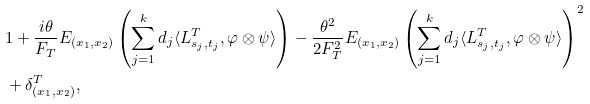<formula> <loc_0><loc_0><loc_500><loc_500>& 1 + \frac { i \theta } { F _ { T } } E _ { ( x _ { 1 } , x _ { 2 } ) } \left ( \sum _ { j = 1 } ^ { k } d _ { j } \langle L ^ { T } _ { s _ { j } , t _ { j } } , \varphi \otimes \psi \rangle \right ) - \frac { \theta ^ { 2 } } { 2 F _ { T } ^ { 2 } } E _ { ( x _ { 1 } , x _ { 2 } ) } \left ( \sum _ { j = 1 } ^ { k } d _ { j } \langle L ^ { T } _ { s _ { j } , t _ { j } } , \varphi \otimes \psi \rangle \right ) ^ { 2 } \\ & + \delta _ { ( x _ { 1 } , x _ { 2 } ) } ^ { T } ,</formula> 